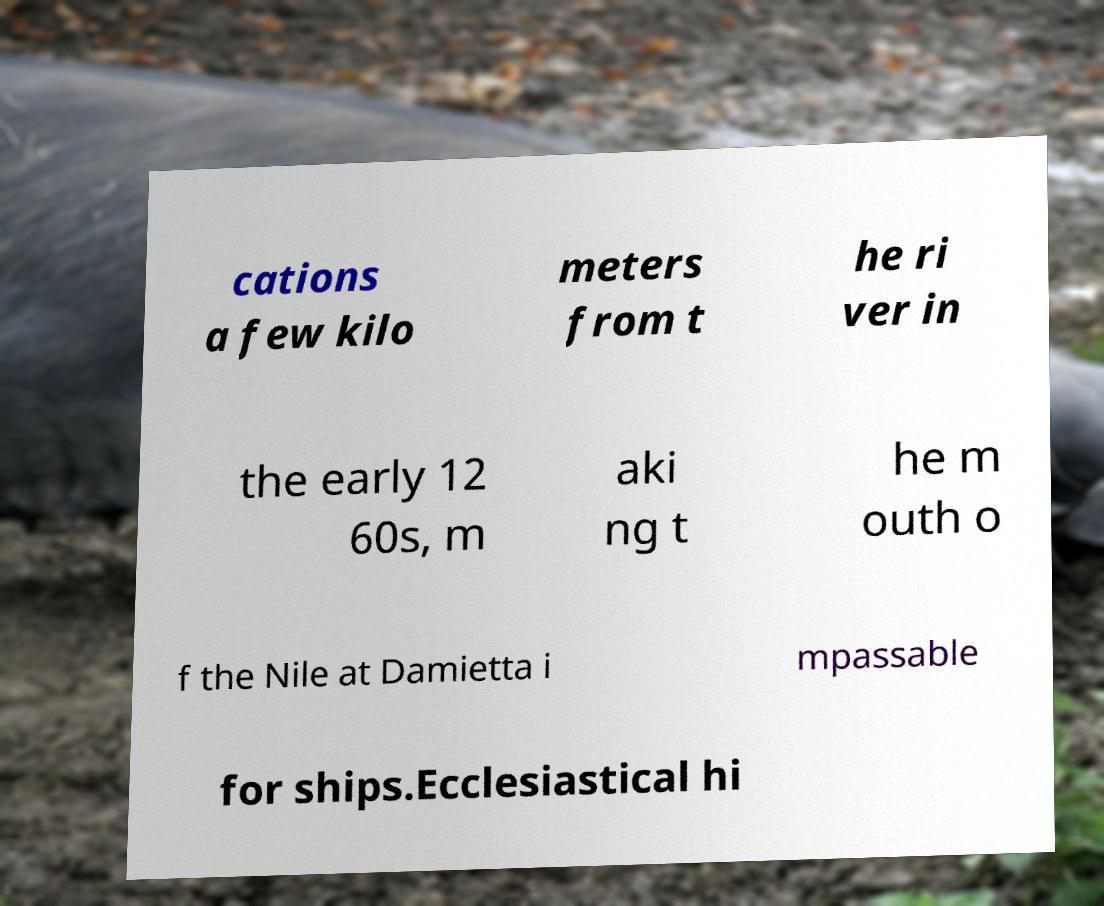For documentation purposes, I need the text within this image transcribed. Could you provide that? cations a few kilo meters from t he ri ver in the early 12 60s, m aki ng t he m outh o f the Nile at Damietta i mpassable for ships.Ecclesiastical hi 